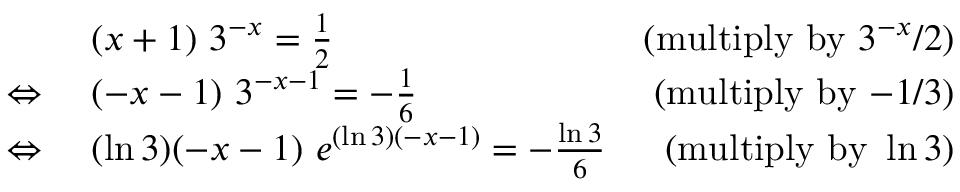Convert formula to latex. <formula><loc_0><loc_0><loc_500><loc_500>{ \begin{array} { r l r } & { ( x + 1 ) \ 3 ^ { - x } = { \frac { 1 } { 2 } } } & { ( { m u l t i p l y b y } 3 ^ { - x } / 2 ) } \\ { \Leftrightarrow \ } & { ( - x - 1 ) \ 3 ^ { - x - 1 } = - { \frac { 1 } { 6 } } } & { ( { m u l t i p l y b y } { - } 1 / 3 ) } \\ { \Leftrightarrow \ } & { ( \ln 3 ) ( - x - 1 ) \ e ^ { ( \ln 3 ) ( - x - 1 ) } = - { \frac { \ln 3 } { 6 } } } & { ( { m u l t i p l y b y } \ln 3 ) } \end{array} }</formula> 